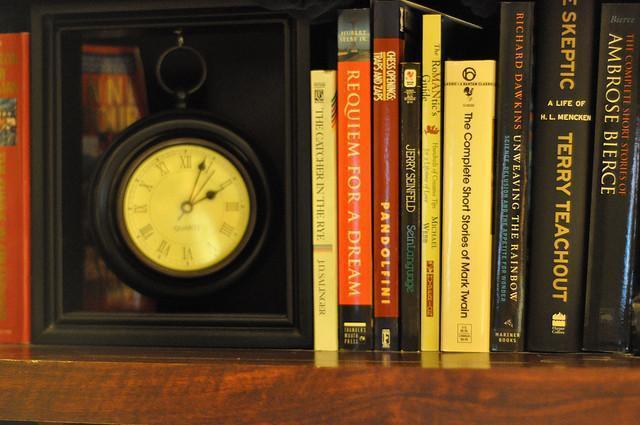How many books are there to the right of the clock?
Give a very brief answer. 9. How many books are in the photo?
Give a very brief answer. 11. How many people are wearing cap?
Give a very brief answer. 0. 